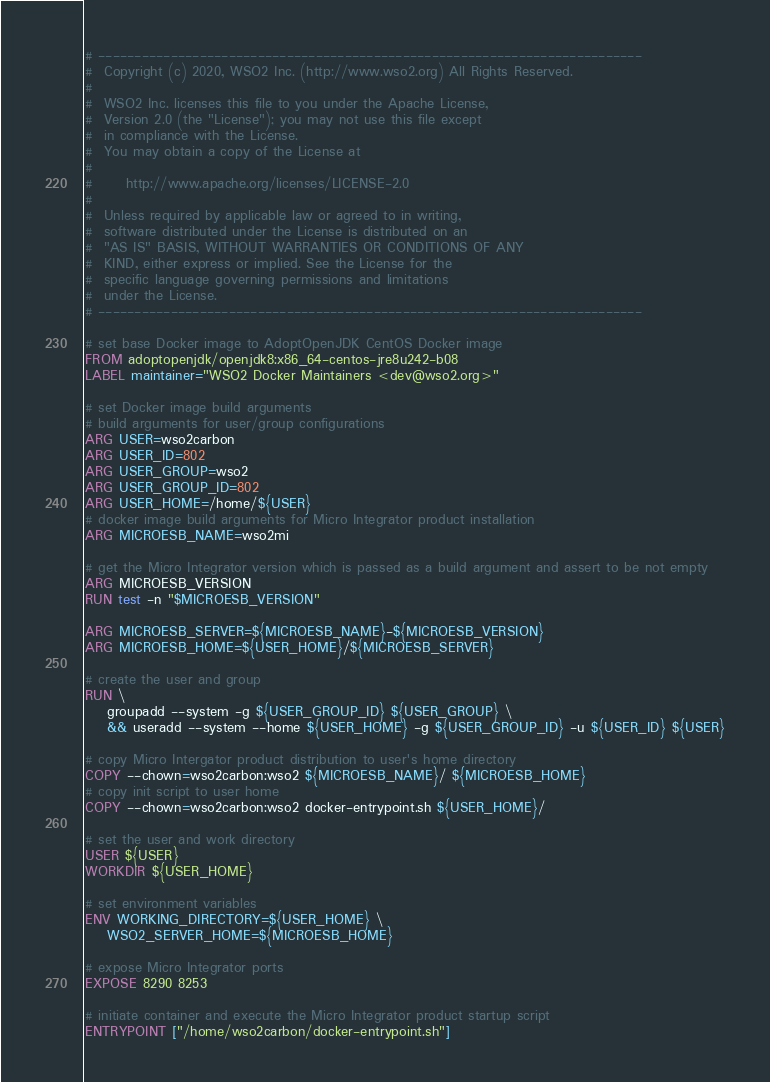<code> <loc_0><loc_0><loc_500><loc_500><_Dockerfile_># ---------------------------------------------------------------------------
#  Copyright (c) 2020, WSO2 Inc. (http://www.wso2.org) All Rights Reserved.
#
#  WSO2 Inc. licenses this file to you under the Apache License,
#  Version 2.0 (the "License"); you may not use this file except
#  in compliance with the License.
#  You may obtain a copy of the License at
#
#      http://www.apache.org/licenses/LICENSE-2.0
#
#  Unless required by applicable law or agreed to in writing,
#  software distributed under the License is distributed on an
#  "AS IS" BASIS, WITHOUT WARRANTIES OR CONDITIONS OF ANY
#  KIND, either express or implied. See the License for the
#  specific language governing permissions and limitations
#  under the License.
# ---------------------------------------------------------------------------

# set base Docker image to AdoptOpenJDK CentOS Docker image
FROM adoptopenjdk/openjdk8:x86_64-centos-jre8u242-b08
LABEL maintainer="WSO2 Docker Maintainers <dev@wso2.org>"

# set Docker image build arguments
# build arguments for user/group configurations
ARG USER=wso2carbon
ARG USER_ID=802
ARG USER_GROUP=wso2
ARG USER_GROUP_ID=802
ARG USER_HOME=/home/${USER}
# docker image build arguments for Micro Integrator product installation
ARG MICROESB_NAME=wso2mi

# get the Micro Integrator version which is passed as a build argument and assert to be not empty
ARG MICROESB_VERSION
RUN test -n "$MICROESB_VERSION"

ARG MICROESB_SERVER=${MICROESB_NAME}-${MICROESB_VERSION}
ARG MICROESB_HOME=${USER_HOME}/${MICROESB_SERVER}

# create the user and group
RUN \
    groupadd --system -g ${USER_GROUP_ID} ${USER_GROUP} \
    && useradd --system --home ${USER_HOME} -g ${USER_GROUP_ID} -u ${USER_ID} ${USER}

# copy Micro Intergator product distribution to user's home directory
COPY --chown=wso2carbon:wso2 ${MICROESB_NAME}/ ${MICROESB_HOME}
# copy init script to user home
COPY --chown=wso2carbon:wso2 docker-entrypoint.sh ${USER_HOME}/

# set the user and work directory
USER ${USER}
WORKDIR ${USER_HOME}

# set environment variables
ENV WORKING_DIRECTORY=${USER_HOME} \
    WSO2_SERVER_HOME=${MICROESB_HOME}

# expose Micro Integrator ports
EXPOSE 8290 8253

# initiate container and execute the Micro Integrator product startup script
ENTRYPOINT ["/home/wso2carbon/docker-entrypoint.sh"]
</code> 